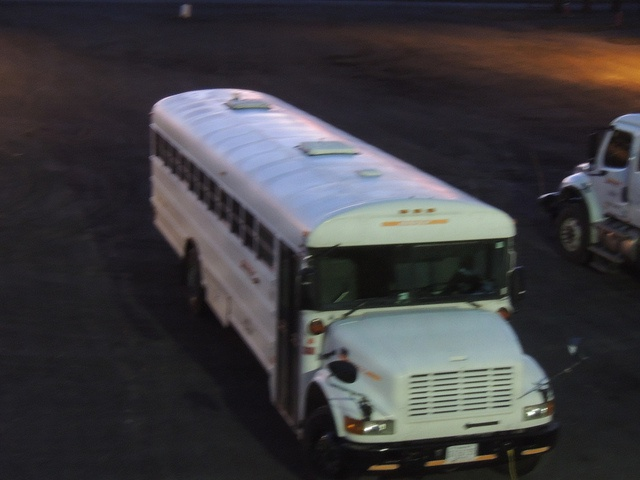Describe the objects in this image and their specific colors. I can see bus in black, darkgray, and gray tones and truck in black and gray tones in this image. 